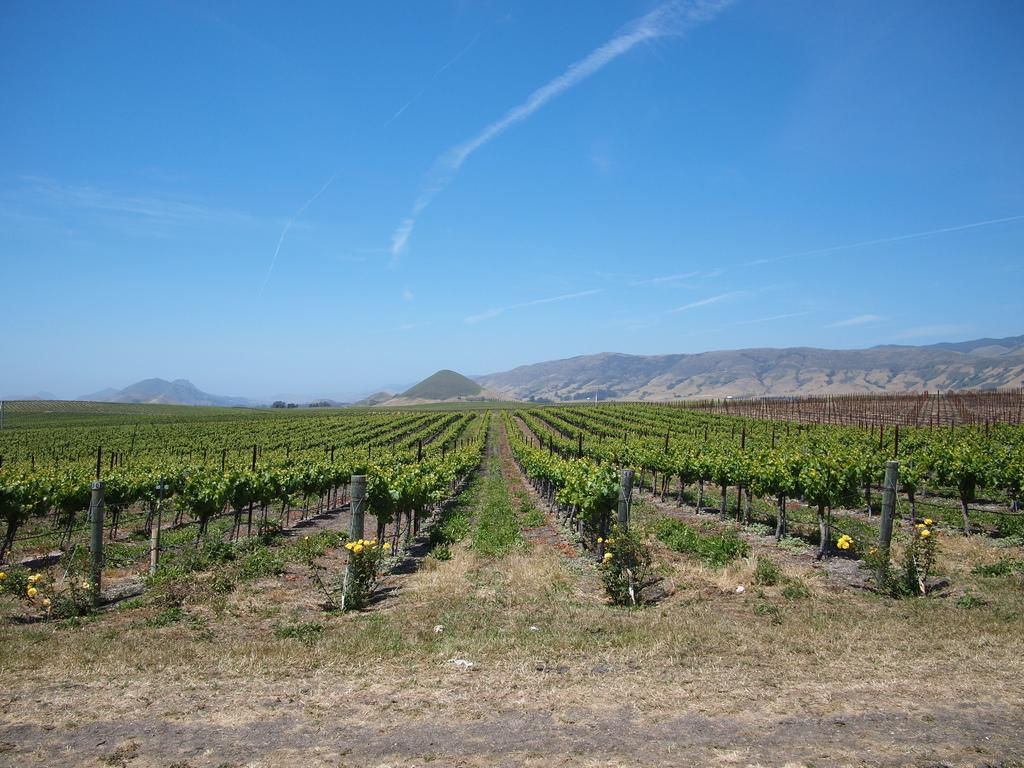What type of vegetation can be seen on the ground in the image? There are many plants on the ground in the image. What is visible at the bottom of the image? The ground is visible at the bottom of the image. What type of ground cover is present in the image? Grass is present on the ground. What can be seen in the background of the image? There is a hill in the background of the image. What is visible in the sky in the image? The sky is visible in the background of the image, and clouds are present. What type of joke is written on the note in the image? There is no note present in the image, so it is not possible to answer that question. 